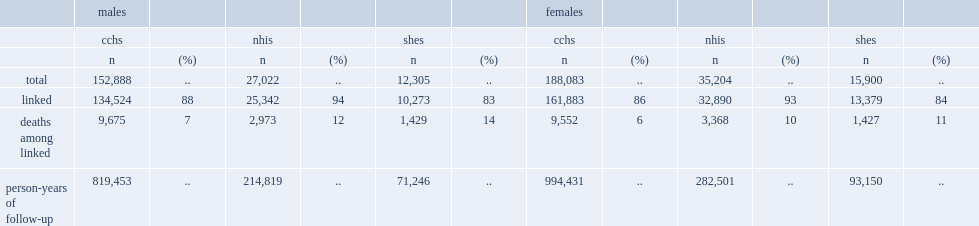What is the percentages of nhis respondents who agreed to data sharing and linkage were successfully linked to national mortality data? 93.5. What is the percentages of shes respondents who agreed to data sharing and linkage were successfully linked to national mortality data? 83.5. Among cchs respondents who successfully linked to national mortality data, how many deaths occurred during 1.8 million person-years of mortality follow-up? 19227. Among nhis respondents who successfully linked to national mortality data,how many deaths occurred during almost half a million person-years of follow-up? 6341. Among shes respondents who successfully linked to national mortality data,how many deaths occurred during 160,000 person-years of follow-up. 2856. 